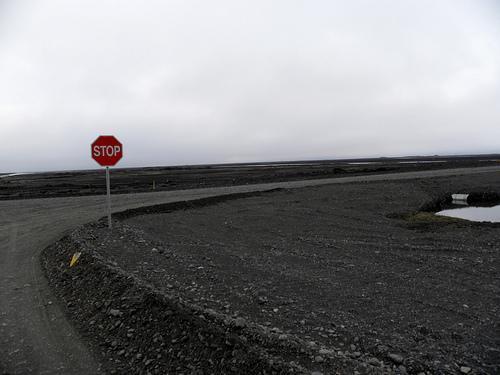How many warning signs on the road?
Give a very brief answer. 1. 